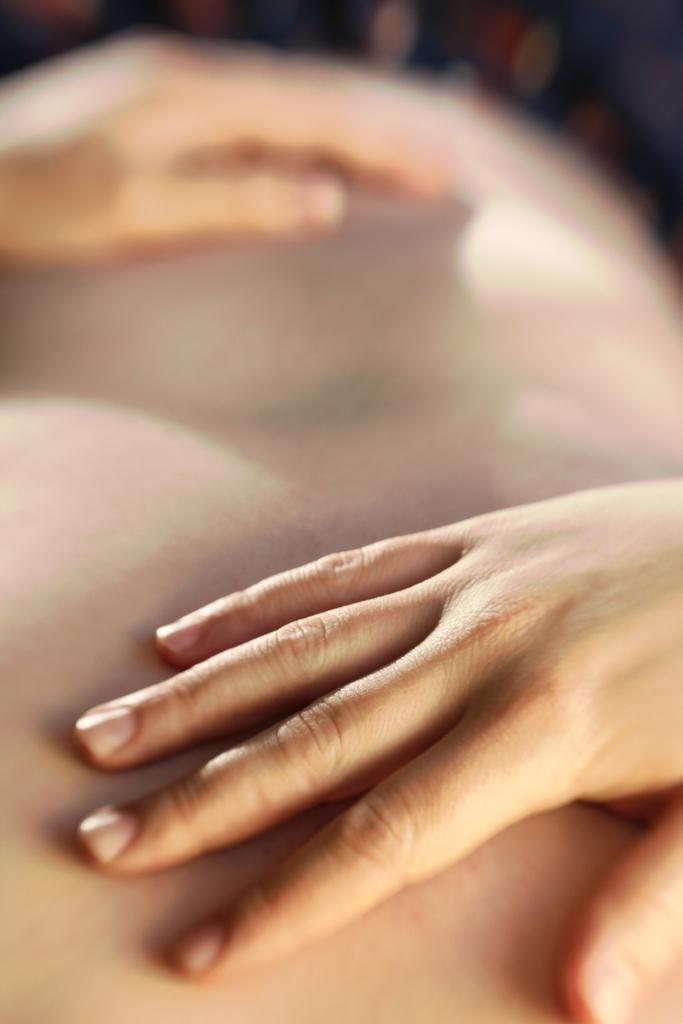What is the main subject of the image? There is a person in the image. What type of observation can be made about the person's knowledge of quantum physics in the image? There is no information about the person's knowledge of quantum physics in the image, so it cannot be determined from the image. 